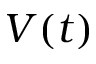<formula> <loc_0><loc_0><loc_500><loc_500>V ( t )</formula> 